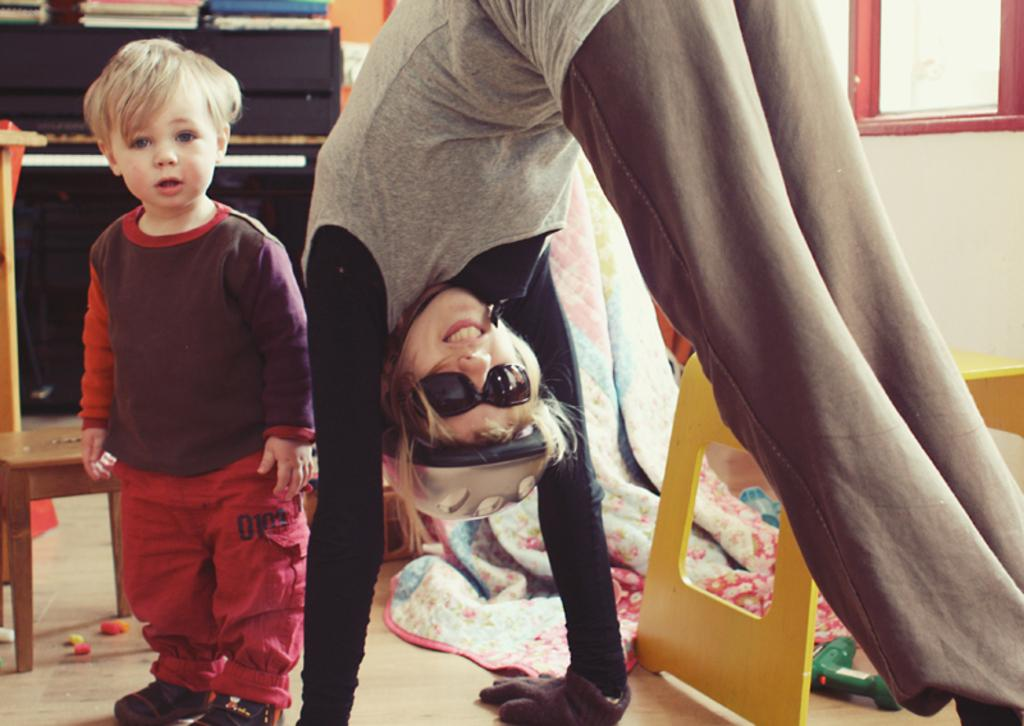What is the child doing in the image? The child is standing in the image. Who is present next to the child? There is a woman at the right side of the image. What protective gear is the woman wearing? The woman is wearing goggles, a helmet, and gloves. What is behind the child and woman? There is a yellow stool and a blanket behind the stool. What can be seen in the background of the image? Other objects are visible in the background. What type of cork is being used to level the foot of the stool in the image? There is no cork or mention of leveling the foot of the stool in the image. 